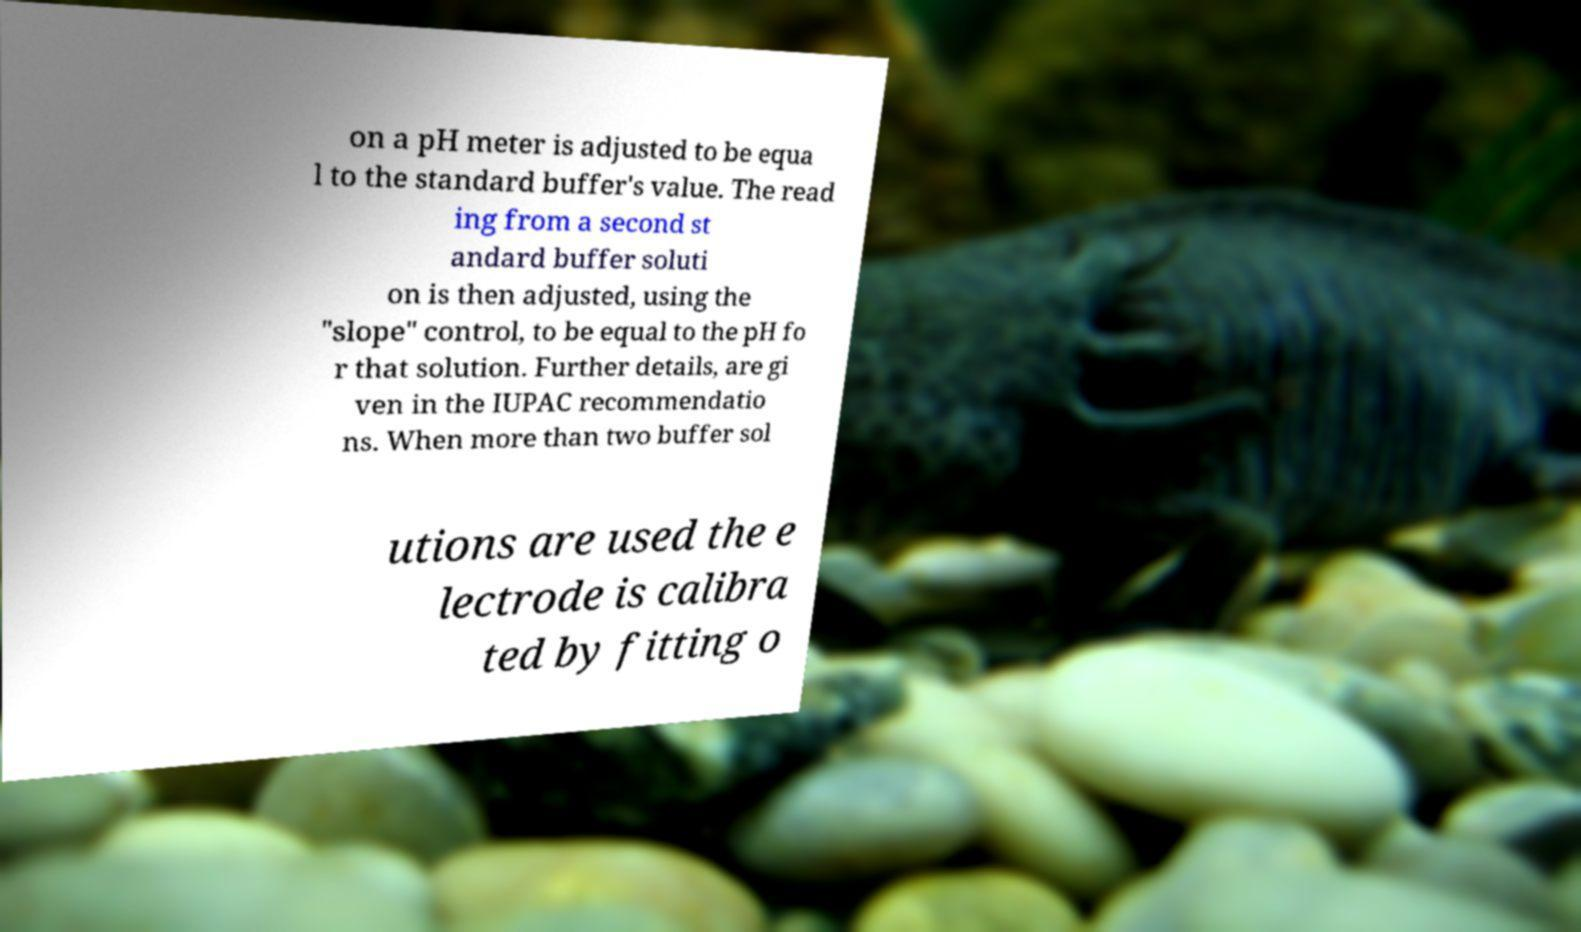Please read and relay the text visible in this image. What does it say? on a pH meter is adjusted to be equa l to the standard buffer's value. The read ing from a second st andard buffer soluti on is then adjusted, using the "slope" control, to be equal to the pH fo r that solution. Further details, are gi ven in the IUPAC recommendatio ns. When more than two buffer sol utions are used the e lectrode is calibra ted by fitting o 